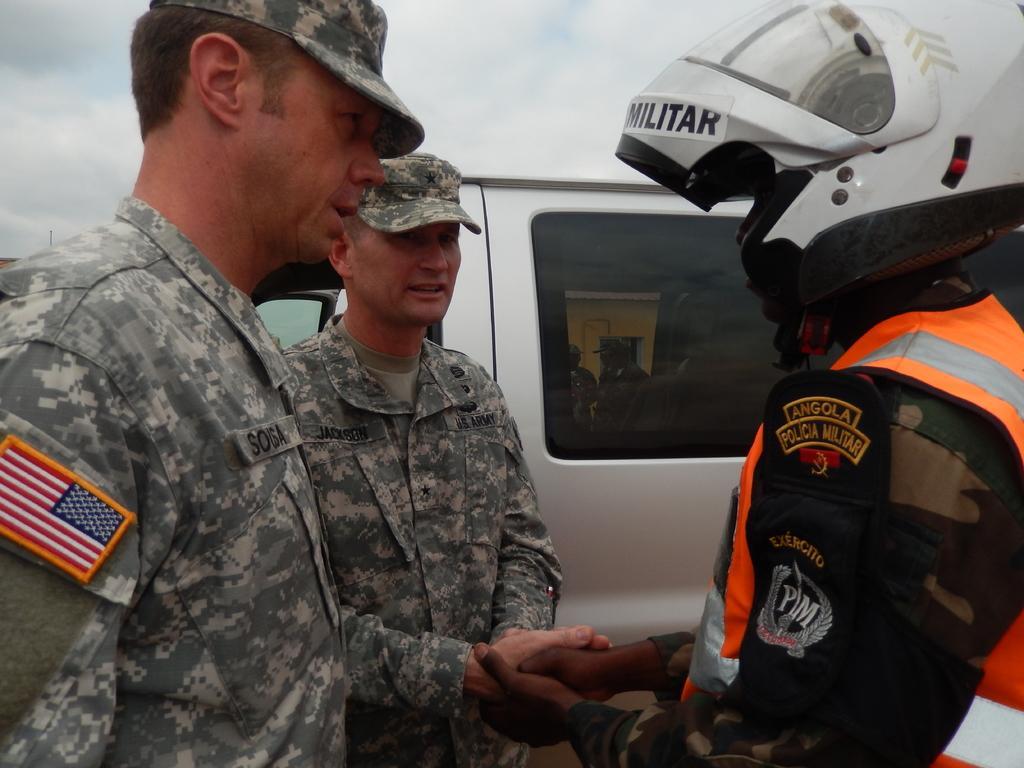Can you describe this image briefly? In this image two persons are wearing uniforms and cap. Right side there is a person wearing a jacket. He is holding a hand of a person. He is wearing helmet. Behind him there is a vehicle. From window of vehicle few persons are visible. Top of image there is sky. 